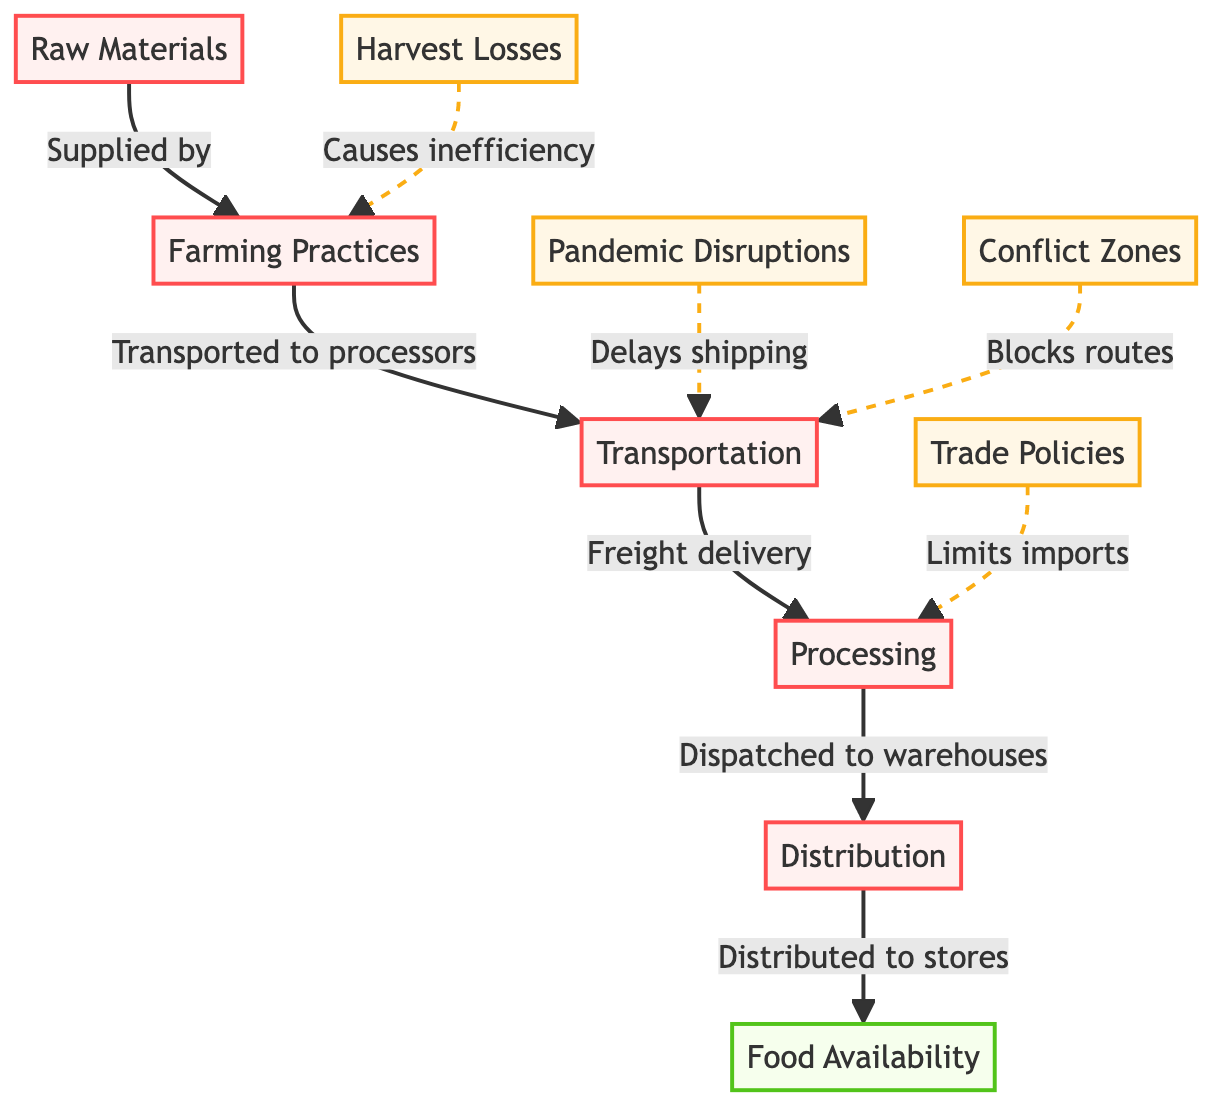What are the input materials in this diagram? The diagram indicates that the input material is "Raw Materials," which is the starting point of the supply chain and is supplied to farming practices.
Answer: Raw Materials How many distinct nodes are present in the diagram? The diagram has five main nodes: Raw Materials, Farming Practices, Transportation, Processing, and Distribution, plus the output node Food Availability, totaling six nodes.
Answer: 6 What type of impact does harvest loss have on farming practices? The diagram describes that harvest losses cause inefficiency in farming practices, emphasizing the negative relationship between these two nodes.
Answer: Causes inefficiency What flows into the processing node from transportation? The flow into the processing node from transportation is indicated as "Freight delivery," showing how goods are moved into processing after transportation.
Answer: Freight delivery What does trade policies limit in this flowchart? The diagram states that trade policies limit imports into the processing stage, illustrating how external regulations affect the food supply chain.
Answer: Limits imports How does the pandemic affect transportation in this diagram? The impact of the pandemic on transportation is shown as "Delays shipping," indicating that pandemic-related disruptions hinder the movement of goods.
Answer: Delays shipping What is the final output of the chain? The final output of the chain, as identified in the diagram, is "Food Availability," representing the end result of the entire supply process.
Answer: Food Availability Which nodes are involved in the distribution process? The nodes involved in distribution are Processing and Distribution, showing that food is dispatched to warehouses and then distributed to stores.
Answer: Processing, Distribution What type of impact blocks routes in this supply chain? The diagram indicates that conflict zones block routes, affecting the transportation node and illustrating how geopolitical issues can disrupt the supply chain.
Answer: Blocks routes 